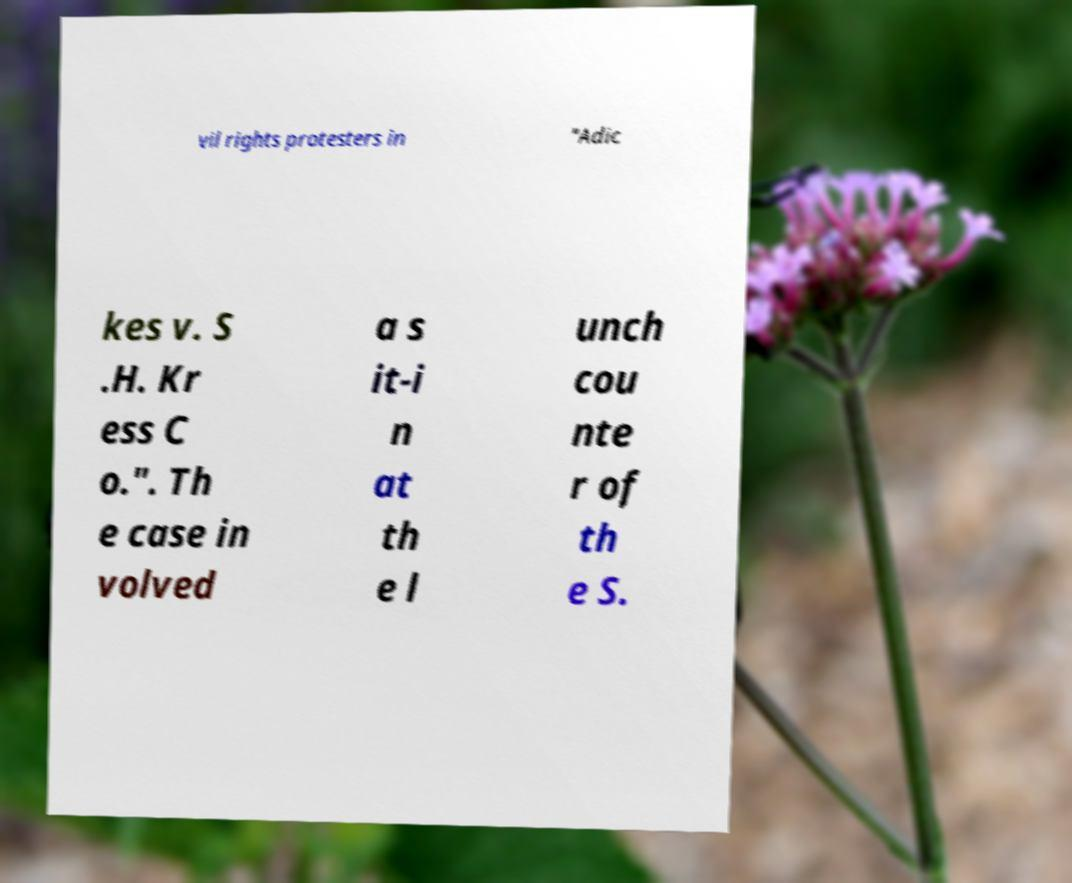Could you extract and type out the text from this image? vil rights protesters in "Adic kes v. S .H. Kr ess C o.". Th e case in volved a s it-i n at th e l unch cou nte r of th e S. 